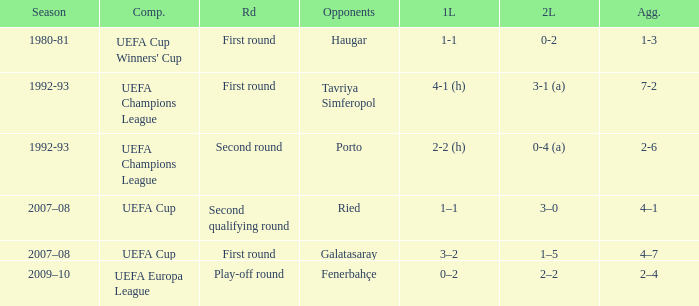 what's the 1st leg where opponents is galatasaray 3–2. 